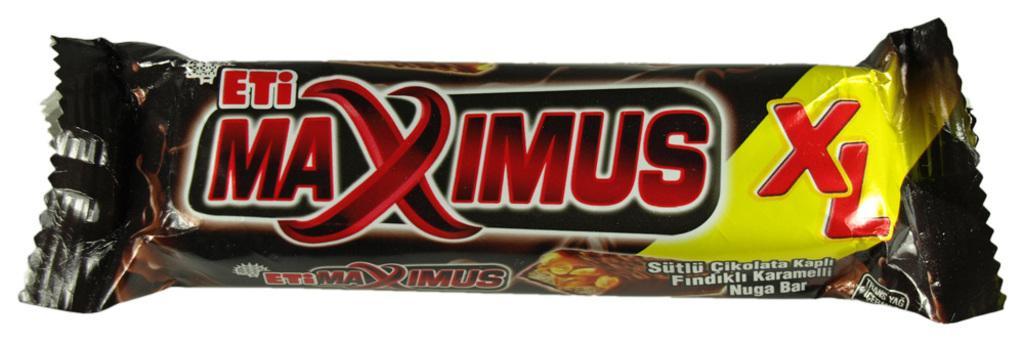Could you give a brief overview of what you see in this image? In this image we can see the chocolate bar and the wrapper is in brown color where we can see some text on it. The background of the image is in white color. 